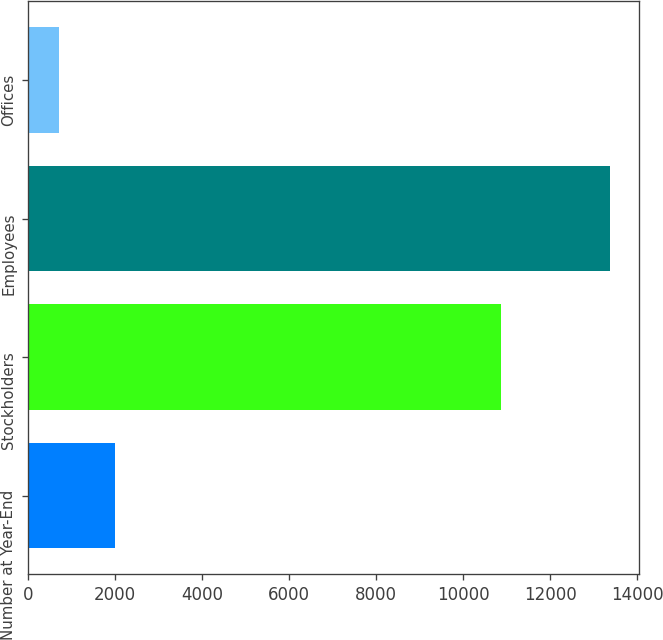<chart> <loc_0><loc_0><loc_500><loc_500><bar_chart><fcel>Number at Year-End<fcel>Stockholders<fcel>Employees<fcel>Offices<nl><fcel>2004<fcel>10857<fcel>13371<fcel>713<nl></chart> 